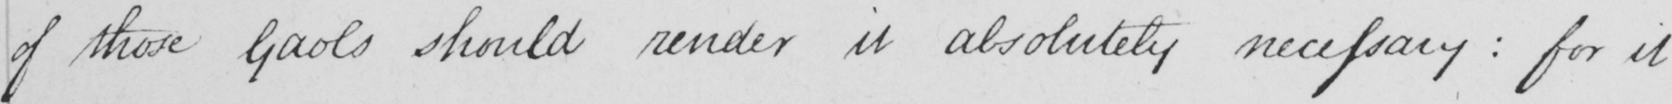What is written in this line of handwriting? of those Gaols should render it absolutely necessary :  for it 